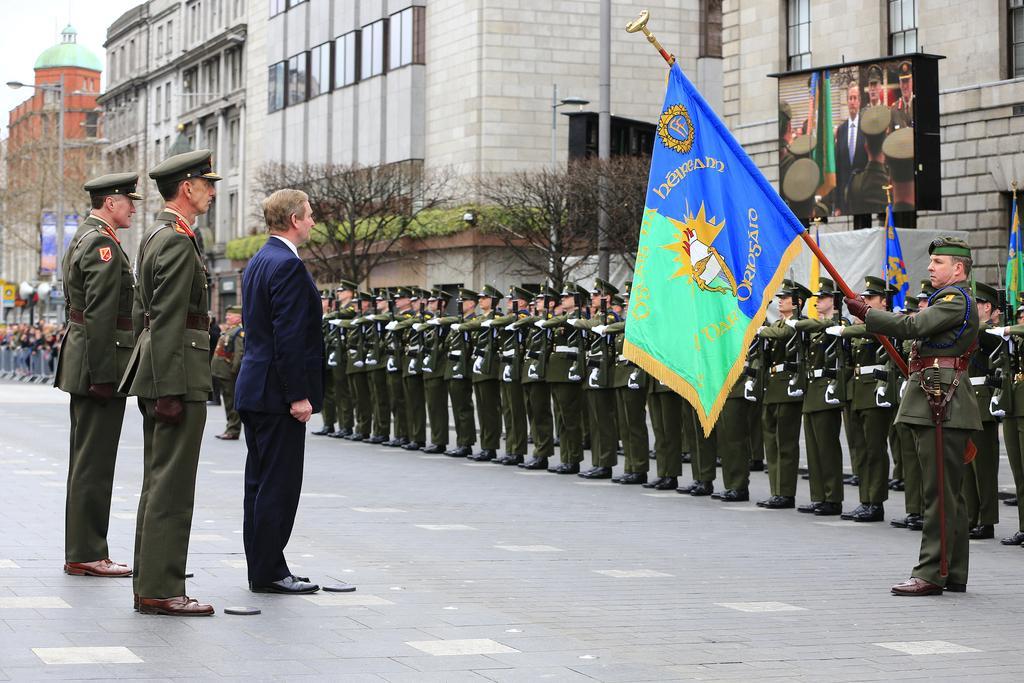How would you summarize this image in a sentence or two? In this picture we can see a group of people standing on the road and a man holding a flag with his hands and in the background we can see flags, trees, screen, plants, poles, lights, buildings with windows and some objects. 